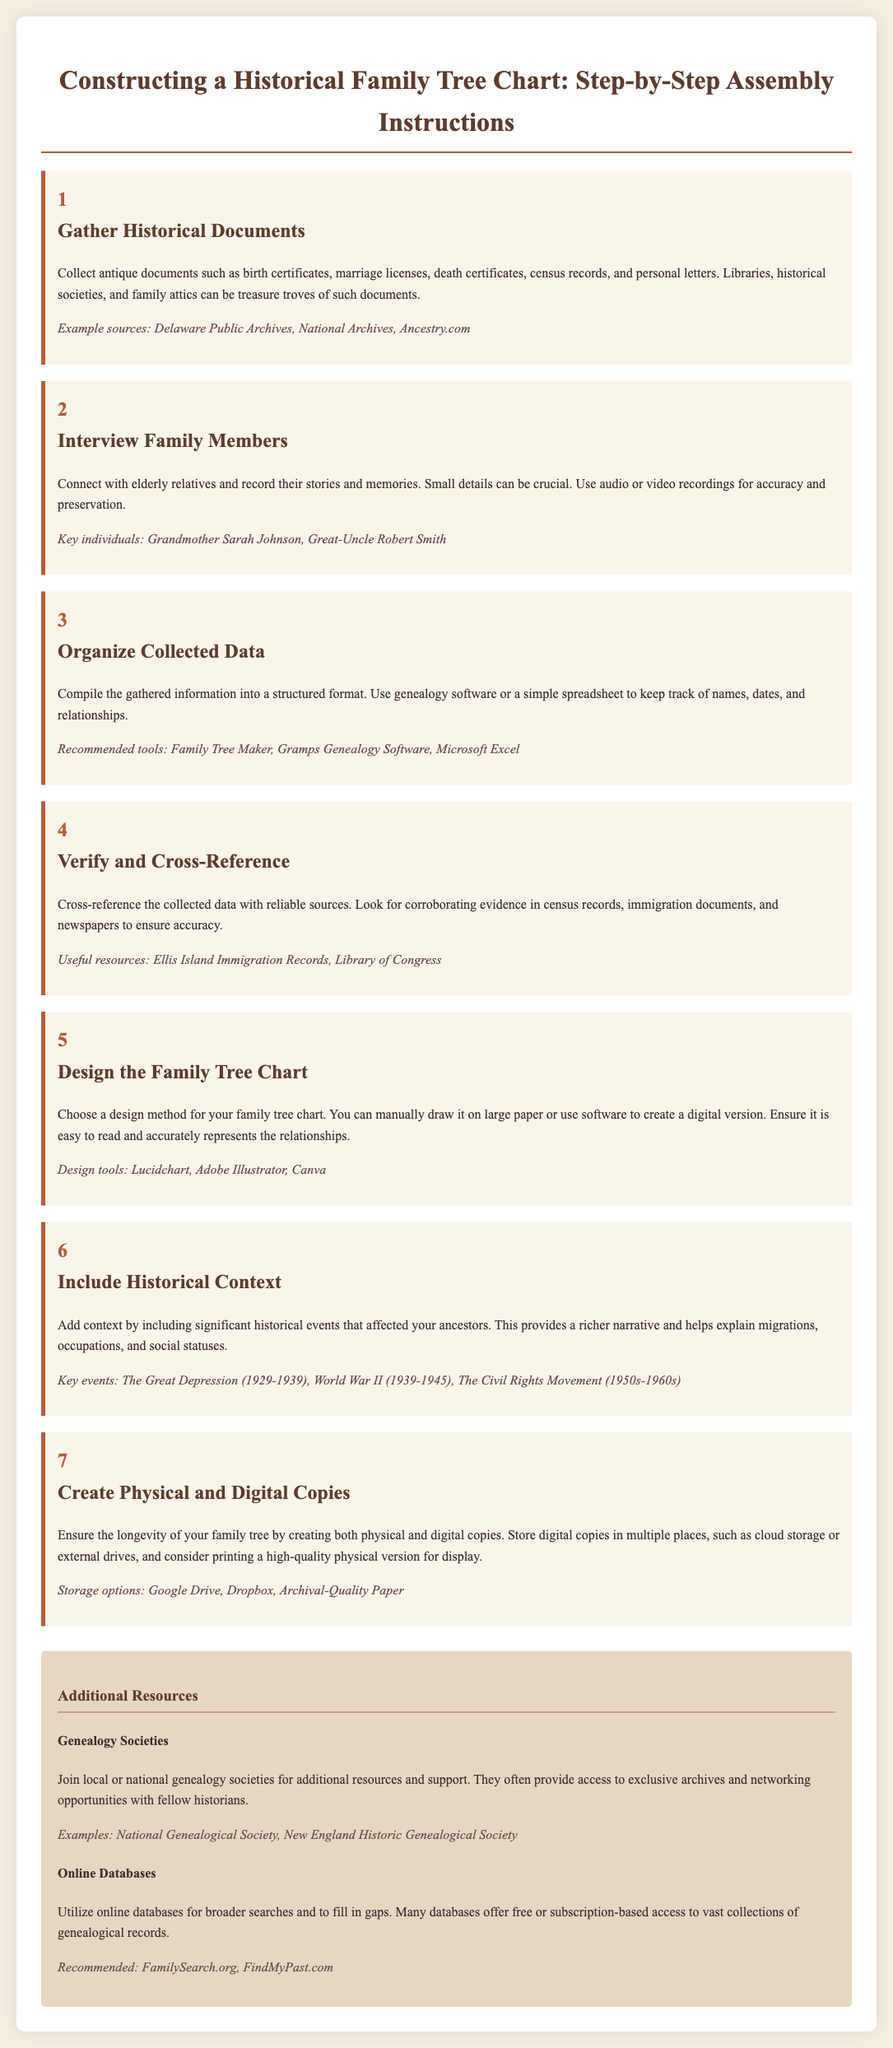What is the first step in constructing a family tree? The first step is to gather historical documents.
Answer: Gather historical documents What type of documents should be collected? The document lists various types of antique documents like certificates and records.
Answer: Birth certificates, marriage licenses, death certificates Which family members are recommended for interviews? The document suggests connecting with elderly relatives for insights.
Answer: Grandmother Sarah Johnson, Great-Uncle Robert Smith What is a recommended tool for organizing data? The document provides examples of tools suitable for organizing genealogy data.
Answer: Family Tree Maker Which historical event is mentioned in the context of including background information? The document lists significant historical events for context in the chart.
Answer: The Great Depression (1929-1939) At what step should you verify and cross-reference your data? This step ensures the accuracy of the gathered information.
Answer: Step 4 What should be created to ensure longevity of the family tree? The document emphasizes the importance of preserving the family tree in different formats.
Answer: Physical and digital copies Which online database is recommended for genealogical records? The document lists online resources for genealogical research.
Answer: FamilySearch.org 